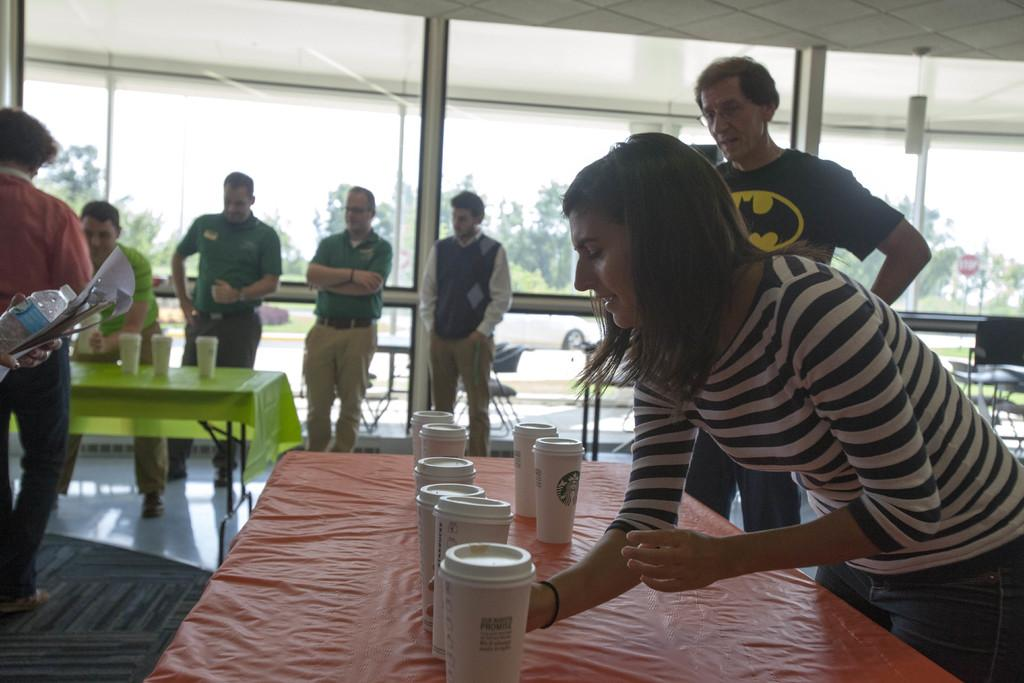What type of space is depicted in the image? There is a room in the image. What furniture is present in the room? There are multiple tables and chairs in the room. What are the people in the image doing? People are standing on the floor in the room. How would you describe the weather or lighting conditions in the image? The background of the image is sunny. What type of company is being held in the room in the image? There is no indication of a company or gathering in the image; it simply shows a room with tables, chairs, and people standing. What kind of dinner is being served on the tables in the image? There is no dinner or food visible in the image; only tables, chairs, and people standing are present. 